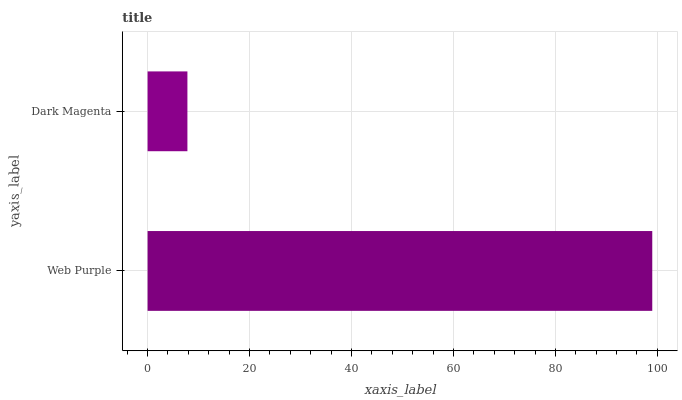Is Dark Magenta the minimum?
Answer yes or no. Yes. Is Web Purple the maximum?
Answer yes or no. Yes. Is Dark Magenta the maximum?
Answer yes or no. No. Is Web Purple greater than Dark Magenta?
Answer yes or no. Yes. Is Dark Magenta less than Web Purple?
Answer yes or no. Yes. Is Dark Magenta greater than Web Purple?
Answer yes or no. No. Is Web Purple less than Dark Magenta?
Answer yes or no. No. Is Web Purple the high median?
Answer yes or no. Yes. Is Dark Magenta the low median?
Answer yes or no. Yes. Is Dark Magenta the high median?
Answer yes or no. No. Is Web Purple the low median?
Answer yes or no. No. 